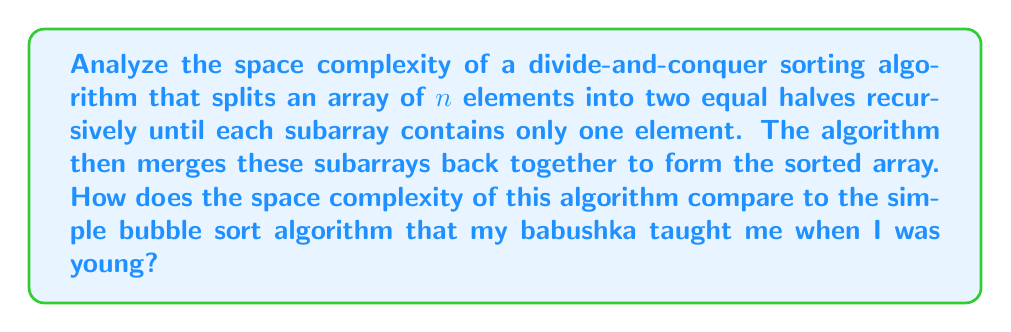Give your solution to this math problem. Let's analyze this step-by-step:

1) The divide-and-conquer algorithm described is likely the Merge Sort algorithm.

2) In Merge Sort, we recursively divide the array until we reach subarrays of size 1. This doesn't require additional space.

3) The space complexity comes from the merging step. At each level of recursion, we need additional space to merge the subarrays.

4) The maximum amount of extra space is used during the final merge, where we merge two sorted halves of the array. This requires an auxiliary array of size $n$.

5) Therefore, the space complexity of Merge Sort is $O(n)$.

6) Comparing this to Bubble Sort:
   - Bubble Sort is an in-place sorting algorithm.
   - It only requires a constant amount of extra space for swapping elements.
   - The space complexity of Bubble Sort is $O(1)$.

7) In terms of space complexity:
   $$\text{Bubble Sort } O(1) < \text{Merge Sort } O(n)$$

8) However, it's worth noting that Merge Sort has a time complexity of $O(n \log n)$, which is generally much faster than Bubble Sort's $O(n^2)$ for large datasets.
Answer: The space complexity of the described divide-and-conquer sorting algorithm (Merge Sort) is $O(n)$, which is higher than the $O(1)$ space complexity of Bubble Sort. 